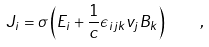Convert formula to latex. <formula><loc_0><loc_0><loc_500><loc_500>J _ { i } = \sigma \left ( E _ { i } + \frac { 1 } { c } \epsilon _ { i j k } v _ { j } B _ { k } \right ) \quad ,</formula> 